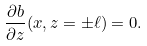<formula> <loc_0><loc_0><loc_500><loc_500>\frac { \partial b } { \partial z } ( x , z = \pm \ell ) = 0 .</formula> 